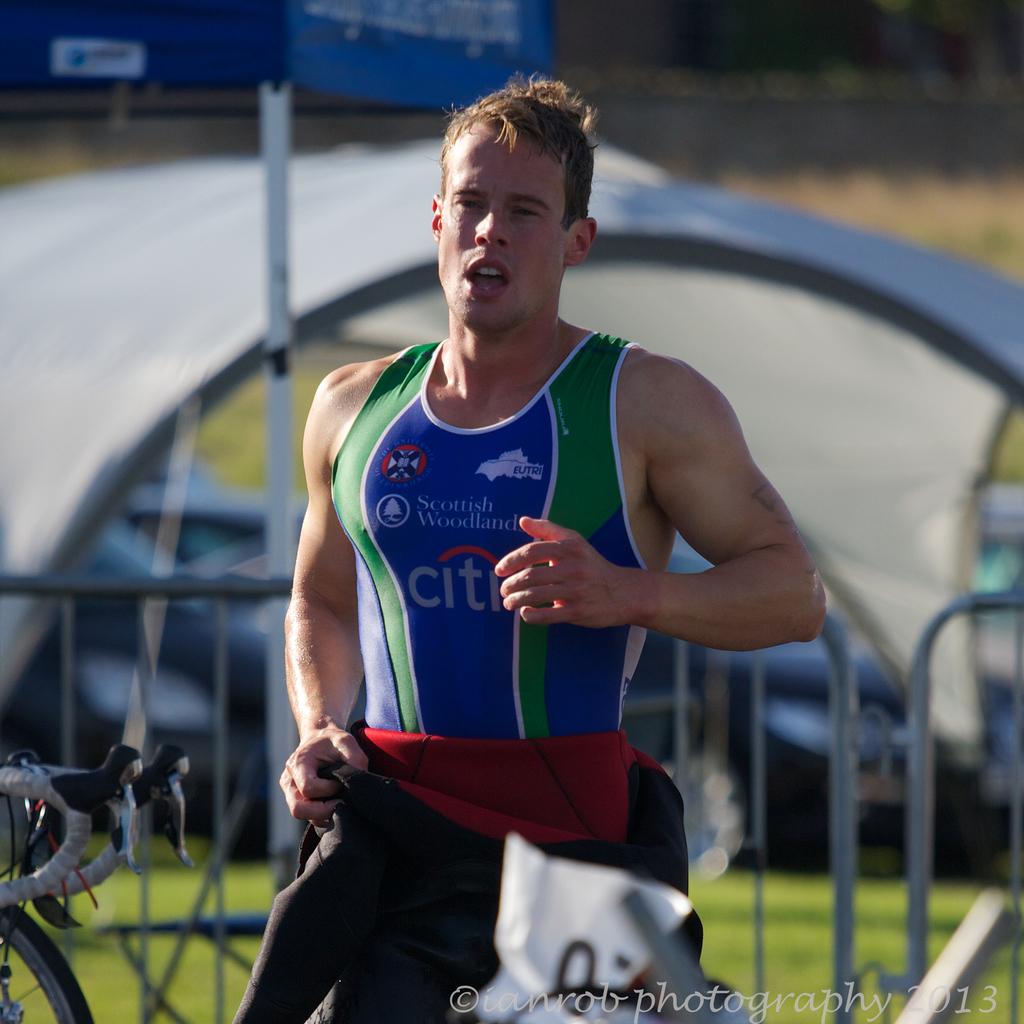What bank has a logo on the man's tank top?
Keep it short and to the point. Citi. Who sponsored this event?
Provide a succinct answer. Citi. 